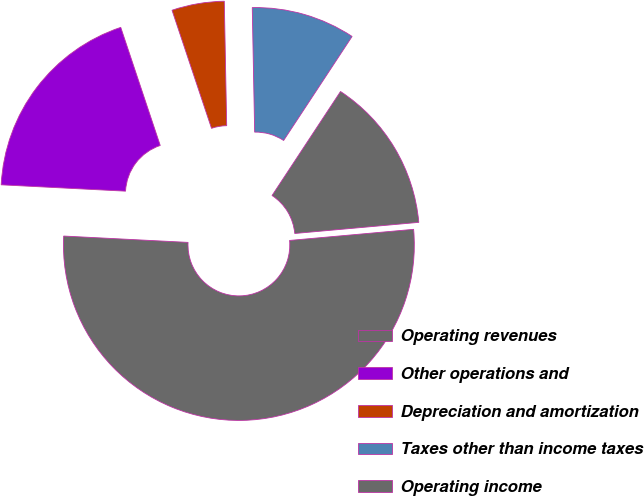Convert chart to OTSL. <chart><loc_0><loc_0><loc_500><loc_500><pie_chart><fcel>Operating revenues<fcel>Other operations and<fcel>Depreciation and amortization<fcel>Taxes other than income taxes<fcel>Operating income<nl><fcel>52.23%<fcel>19.05%<fcel>4.83%<fcel>9.57%<fcel>14.31%<nl></chart> 